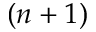<formula> <loc_0><loc_0><loc_500><loc_500>( n + 1 )</formula> 